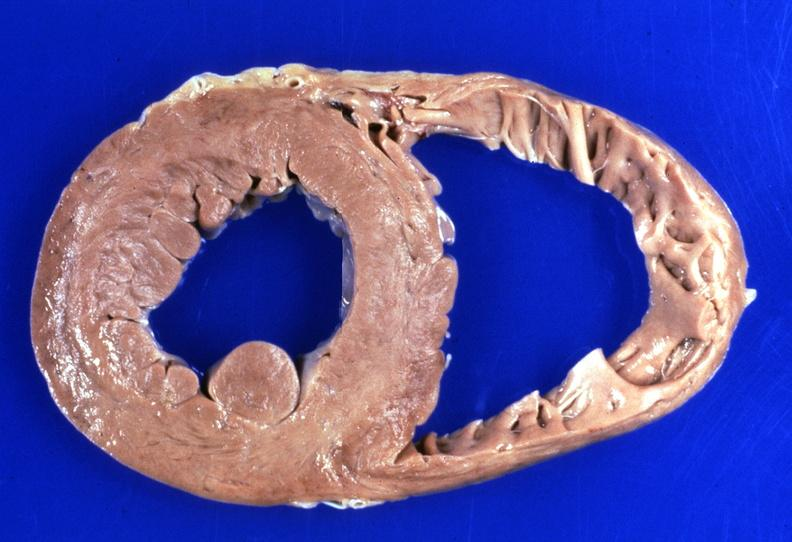s artery present?
Answer the question using a single word or phrase. No 